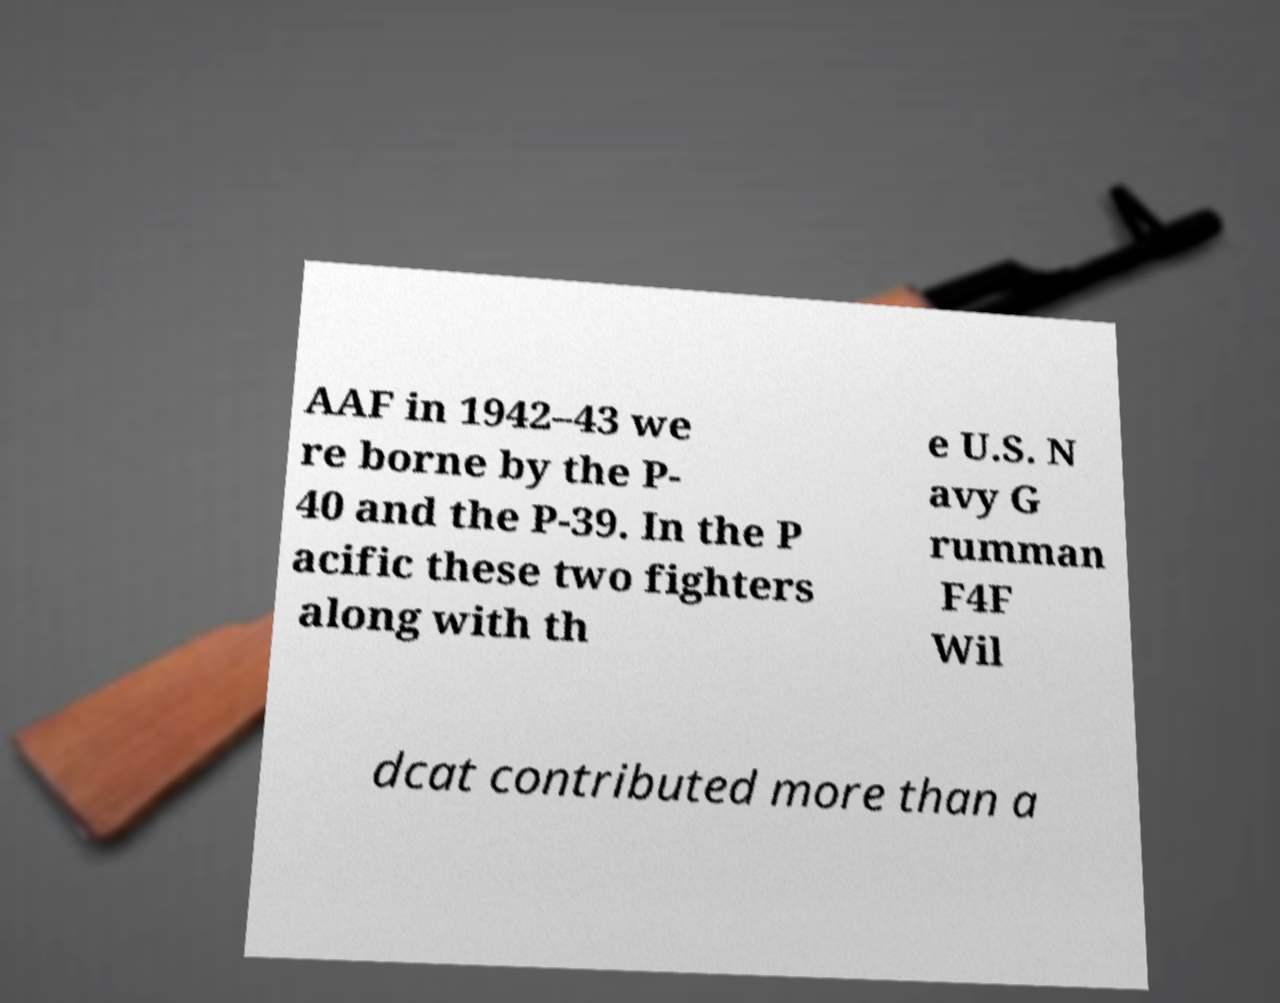For documentation purposes, I need the text within this image transcribed. Could you provide that? AAF in 1942–43 we re borne by the P- 40 and the P-39. In the P acific these two fighters along with th e U.S. N avy G rumman F4F Wil dcat contributed more than a 